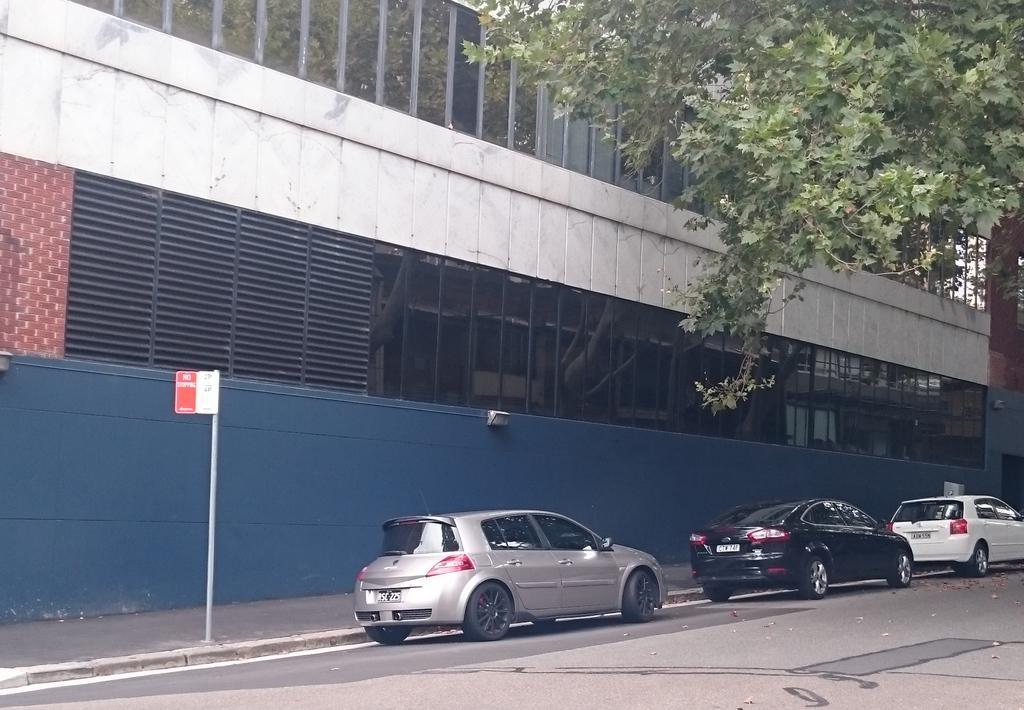Can you describe this image briefly? In the foreground of this image, there are cars placed side to a road and we can also see a pole on the side path. In the background, there is a building and also a tree in the top right corner. 